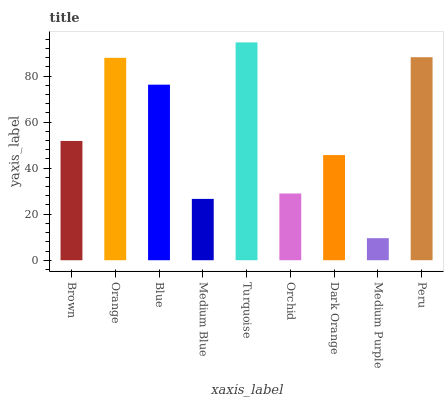Is Medium Purple the minimum?
Answer yes or no. Yes. Is Turquoise the maximum?
Answer yes or no. Yes. Is Orange the minimum?
Answer yes or no. No. Is Orange the maximum?
Answer yes or no. No. Is Orange greater than Brown?
Answer yes or no. Yes. Is Brown less than Orange?
Answer yes or no. Yes. Is Brown greater than Orange?
Answer yes or no. No. Is Orange less than Brown?
Answer yes or no. No. Is Brown the high median?
Answer yes or no. Yes. Is Brown the low median?
Answer yes or no. Yes. Is Dark Orange the high median?
Answer yes or no. No. Is Turquoise the low median?
Answer yes or no. No. 